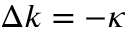Convert formula to latex. <formula><loc_0><loc_0><loc_500><loc_500>\Delta k = - \kappa</formula> 